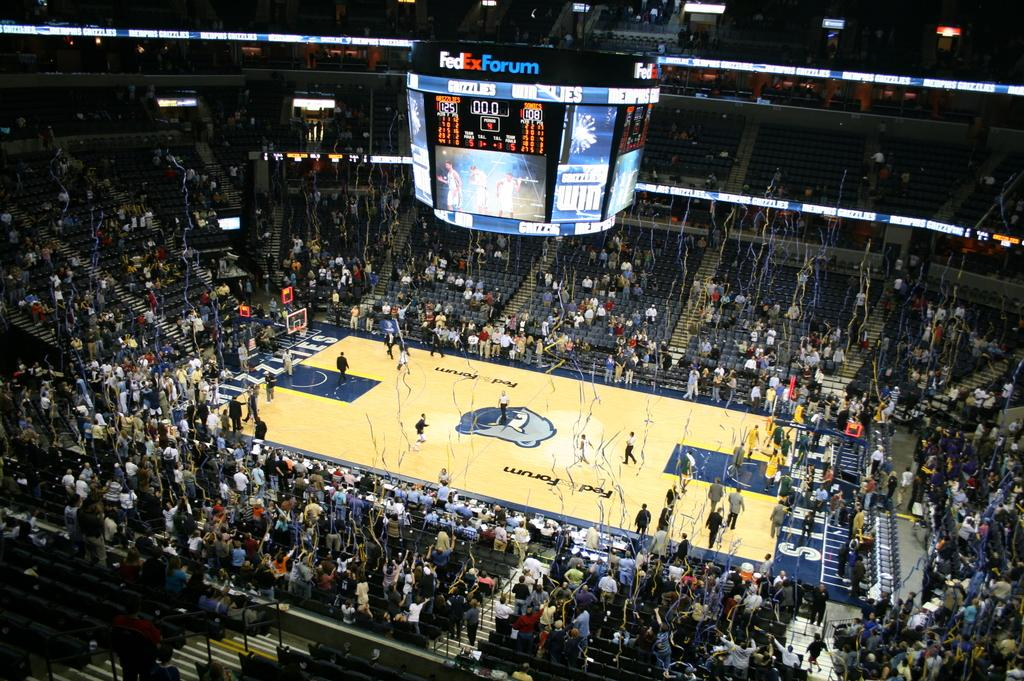<image>
Provide a brief description of the given image. The fedex forum arena showing a basketball team 